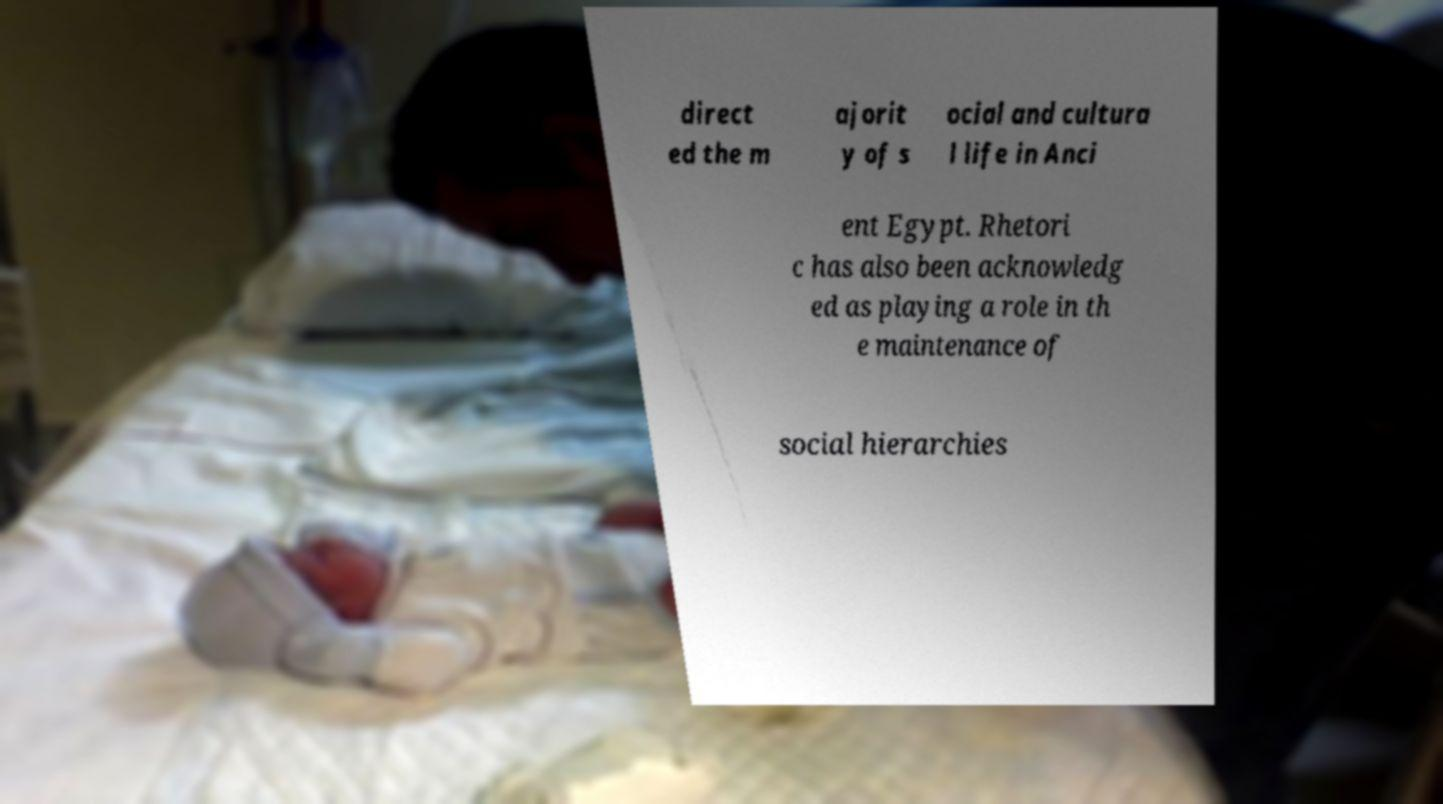There's text embedded in this image that I need extracted. Can you transcribe it verbatim? direct ed the m ajorit y of s ocial and cultura l life in Anci ent Egypt. Rhetori c has also been acknowledg ed as playing a role in th e maintenance of social hierarchies 